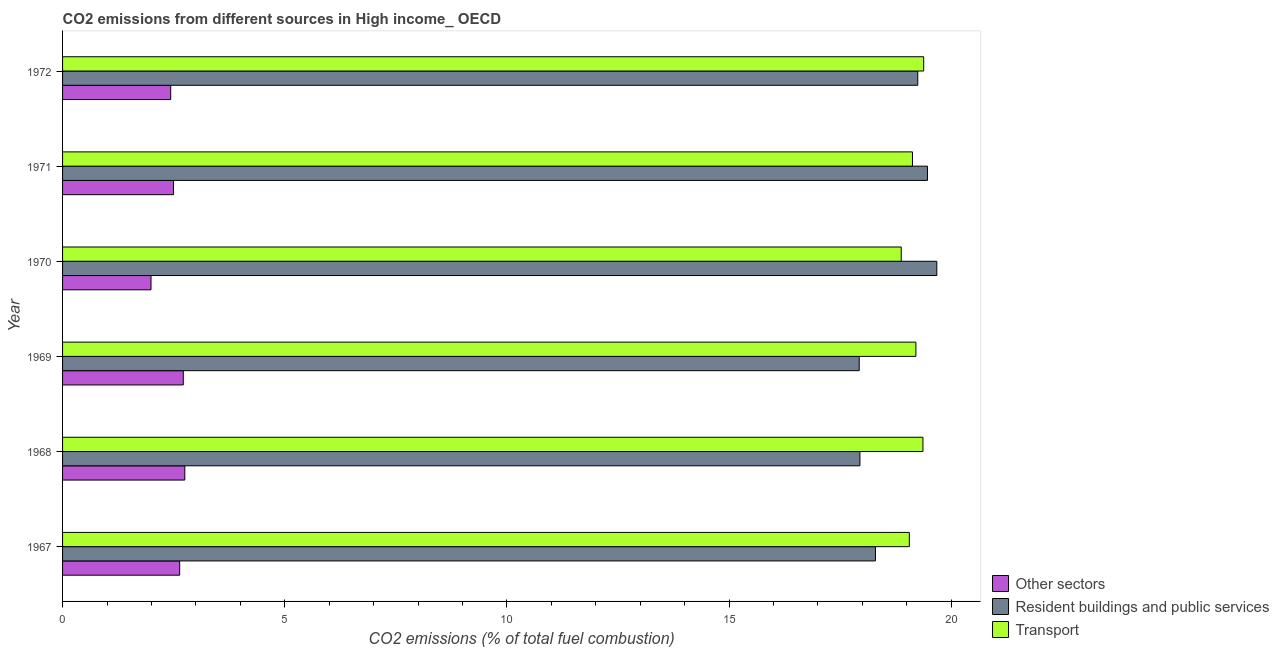How many different coloured bars are there?
Provide a succinct answer. 3. Are the number of bars on each tick of the Y-axis equal?
Keep it short and to the point. Yes. How many bars are there on the 5th tick from the top?
Your answer should be compact. 3. How many bars are there on the 3rd tick from the bottom?
Your answer should be very brief. 3. What is the label of the 5th group of bars from the top?
Keep it short and to the point. 1968. What is the percentage of co2 emissions from other sectors in 1972?
Provide a short and direct response. 2.43. Across all years, what is the maximum percentage of co2 emissions from other sectors?
Your answer should be compact. 2.75. Across all years, what is the minimum percentage of co2 emissions from resident buildings and public services?
Your answer should be compact. 17.93. In which year was the percentage of co2 emissions from other sectors maximum?
Your answer should be compact. 1968. In which year was the percentage of co2 emissions from transport minimum?
Your answer should be compact. 1970. What is the total percentage of co2 emissions from resident buildings and public services in the graph?
Your answer should be very brief. 112.57. What is the difference between the percentage of co2 emissions from resident buildings and public services in 1967 and that in 1969?
Offer a very short reply. 0.36. What is the difference between the percentage of co2 emissions from transport in 1968 and the percentage of co2 emissions from resident buildings and public services in 1969?
Offer a terse response. 1.43. What is the average percentage of co2 emissions from transport per year?
Your answer should be very brief. 19.17. In the year 1972, what is the difference between the percentage of co2 emissions from transport and percentage of co2 emissions from other sectors?
Make the answer very short. 16.95. Is the percentage of co2 emissions from other sectors in 1968 less than that in 1970?
Give a very brief answer. No. What is the difference between the highest and the second highest percentage of co2 emissions from transport?
Ensure brevity in your answer.  0.02. What is the difference between the highest and the lowest percentage of co2 emissions from other sectors?
Offer a terse response. 0.76. In how many years, is the percentage of co2 emissions from other sectors greater than the average percentage of co2 emissions from other sectors taken over all years?
Provide a succinct answer. 3. What does the 2nd bar from the top in 1972 represents?
Keep it short and to the point. Resident buildings and public services. What does the 1st bar from the bottom in 1970 represents?
Offer a very short reply. Other sectors. Is it the case that in every year, the sum of the percentage of co2 emissions from other sectors and percentage of co2 emissions from resident buildings and public services is greater than the percentage of co2 emissions from transport?
Provide a succinct answer. Yes. How many bars are there?
Offer a terse response. 18. Are all the bars in the graph horizontal?
Your answer should be very brief. Yes. What is the difference between two consecutive major ticks on the X-axis?
Your answer should be compact. 5. Does the graph contain any zero values?
Keep it short and to the point. No. Does the graph contain grids?
Your answer should be compact. No. How are the legend labels stacked?
Provide a short and direct response. Vertical. What is the title of the graph?
Make the answer very short. CO2 emissions from different sources in High income_ OECD. Does "Total employers" appear as one of the legend labels in the graph?
Provide a succinct answer. No. What is the label or title of the X-axis?
Keep it short and to the point. CO2 emissions (% of total fuel combustion). What is the CO2 emissions (% of total fuel combustion) in Other sectors in 1967?
Your answer should be compact. 2.64. What is the CO2 emissions (% of total fuel combustion) of Resident buildings and public services in 1967?
Provide a short and direct response. 18.3. What is the CO2 emissions (% of total fuel combustion) of Transport in 1967?
Provide a short and direct response. 19.06. What is the CO2 emissions (% of total fuel combustion) in Other sectors in 1968?
Provide a short and direct response. 2.75. What is the CO2 emissions (% of total fuel combustion) of Resident buildings and public services in 1968?
Ensure brevity in your answer.  17.95. What is the CO2 emissions (% of total fuel combustion) of Transport in 1968?
Provide a short and direct response. 19.37. What is the CO2 emissions (% of total fuel combustion) of Other sectors in 1969?
Your answer should be very brief. 2.72. What is the CO2 emissions (% of total fuel combustion) of Resident buildings and public services in 1969?
Ensure brevity in your answer.  17.93. What is the CO2 emissions (% of total fuel combustion) of Transport in 1969?
Keep it short and to the point. 19.21. What is the CO2 emissions (% of total fuel combustion) of Other sectors in 1970?
Provide a succinct answer. 1.99. What is the CO2 emissions (% of total fuel combustion) of Resident buildings and public services in 1970?
Your response must be concise. 19.68. What is the CO2 emissions (% of total fuel combustion) of Transport in 1970?
Your response must be concise. 18.88. What is the CO2 emissions (% of total fuel combustion) of Other sectors in 1971?
Provide a short and direct response. 2.5. What is the CO2 emissions (% of total fuel combustion) of Resident buildings and public services in 1971?
Your response must be concise. 19.47. What is the CO2 emissions (% of total fuel combustion) in Transport in 1971?
Provide a short and direct response. 19.13. What is the CO2 emissions (% of total fuel combustion) of Other sectors in 1972?
Keep it short and to the point. 2.43. What is the CO2 emissions (% of total fuel combustion) of Resident buildings and public services in 1972?
Your response must be concise. 19.25. What is the CO2 emissions (% of total fuel combustion) in Transport in 1972?
Offer a terse response. 19.38. Across all years, what is the maximum CO2 emissions (% of total fuel combustion) in Other sectors?
Provide a short and direct response. 2.75. Across all years, what is the maximum CO2 emissions (% of total fuel combustion) in Resident buildings and public services?
Make the answer very short. 19.68. Across all years, what is the maximum CO2 emissions (% of total fuel combustion) in Transport?
Give a very brief answer. 19.38. Across all years, what is the minimum CO2 emissions (% of total fuel combustion) of Other sectors?
Offer a very short reply. 1.99. Across all years, what is the minimum CO2 emissions (% of total fuel combustion) in Resident buildings and public services?
Your response must be concise. 17.93. Across all years, what is the minimum CO2 emissions (% of total fuel combustion) of Transport?
Provide a succinct answer. 18.88. What is the total CO2 emissions (% of total fuel combustion) of Other sectors in the graph?
Give a very brief answer. 15.02. What is the total CO2 emissions (% of total fuel combustion) in Resident buildings and public services in the graph?
Offer a very short reply. 112.57. What is the total CO2 emissions (% of total fuel combustion) in Transport in the graph?
Provide a succinct answer. 115.02. What is the difference between the CO2 emissions (% of total fuel combustion) in Other sectors in 1967 and that in 1968?
Your response must be concise. -0.12. What is the difference between the CO2 emissions (% of total fuel combustion) of Resident buildings and public services in 1967 and that in 1968?
Offer a terse response. 0.35. What is the difference between the CO2 emissions (% of total fuel combustion) in Transport in 1967 and that in 1968?
Ensure brevity in your answer.  -0.31. What is the difference between the CO2 emissions (% of total fuel combustion) in Other sectors in 1967 and that in 1969?
Offer a terse response. -0.08. What is the difference between the CO2 emissions (% of total fuel combustion) of Resident buildings and public services in 1967 and that in 1969?
Make the answer very short. 0.37. What is the difference between the CO2 emissions (% of total fuel combustion) of Transport in 1967 and that in 1969?
Give a very brief answer. -0.15. What is the difference between the CO2 emissions (% of total fuel combustion) in Other sectors in 1967 and that in 1970?
Give a very brief answer. 0.65. What is the difference between the CO2 emissions (% of total fuel combustion) in Resident buildings and public services in 1967 and that in 1970?
Your response must be concise. -1.38. What is the difference between the CO2 emissions (% of total fuel combustion) in Transport in 1967 and that in 1970?
Your response must be concise. 0.18. What is the difference between the CO2 emissions (% of total fuel combustion) of Other sectors in 1967 and that in 1971?
Offer a terse response. 0.14. What is the difference between the CO2 emissions (% of total fuel combustion) in Resident buildings and public services in 1967 and that in 1971?
Give a very brief answer. -1.17. What is the difference between the CO2 emissions (% of total fuel combustion) of Transport in 1967 and that in 1971?
Ensure brevity in your answer.  -0.07. What is the difference between the CO2 emissions (% of total fuel combustion) of Other sectors in 1967 and that in 1972?
Make the answer very short. 0.2. What is the difference between the CO2 emissions (% of total fuel combustion) of Resident buildings and public services in 1967 and that in 1972?
Your answer should be compact. -0.95. What is the difference between the CO2 emissions (% of total fuel combustion) of Transport in 1967 and that in 1972?
Offer a very short reply. -0.32. What is the difference between the CO2 emissions (% of total fuel combustion) in Other sectors in 1968 and that in 1969?
Ensure brevity in your answer.  0.03. What is the difference between the CO2 emissions (% of total fuel combustion) in Resident buildings and public services in 1968 and that in 1969?
Give a very brief answer. 0.02. What is the difference between the CO2 emissions (% of total fuel combustion) in Transport in 1968 and that in 1969?
Offer a very short reply. 0.16. What is the difference between the CO2 emissions (% of total fuel combustion) of Other sectors in 1968 and that in 1970?
Offer a terse response. 0.76. What is the difference between the CO2 emissions (% of total fuel combustion) in Resident buildings and public services in 1968 and that in 1970?
Keep it short and to the point. -1.73. What is the difference between the CO2 emissions (% of total fuel combustion) in Transport in 1968 and that in 1970?
Your answer should be very brief. 0.49. What is the difference between the CO2 emissions (% of total fuel combustion) in Other sectors in 1968 and that in 1971?
Keep it short and to the point. 0.26. What is the difference between the CO2 emissions (% of total fuel combustion) of Resident buildings and public services in 1968 and that in 1971?
Provide a short and direct response. -1.52. What is the difference between the CO2 emissions (% of total fuel combustion) of Transport in 1968 and that in 1971?
Make the answer very short. 0.24. What is the difference between the CO2 emissions (% of total fuel combustion) of Other sectors in 1968 and that in 1972?
Keep it short and to the point. 0.32. What is the difference between the CO2 emissions (% of total fuel combustion) in Resident buildings and public services in 1968 and that in 1972?
Ensure brevity in your answer.  -1.3. What is the difference between the CO2 emissions (% of total fuel combustion) of Transport in 1968 and that in 1972?
Offer a terse response. -0.02. What is the difference between the CO2 emissions (% of total fuel combustion) in Other sectors in 1969 and that in 1970?
Offer a terse response. 0.73. What is the difference between the CO2 emissions (% of total fuel combustion) of Resident buildings and public services in 1969 and that in 1970?
Offer a terse response. -1.75. What is the difference between the CO2 emissions (% of total fuel combustion) of Transport in 1969 and that in 1970?
Give a very brief answer. 0.33. What is the difference between the CO2 emissions (% of total fuel combustion) of Other sectors in 1969 and that in 1971?
Ensure brevity in your answer.  0.22. What is the difference between the CO2 emissions (% of total fuel combustion) in Resident buildings and public services in 1969 and that in 1971?
Your response must be concise. -1.54. What is the difference between the CO2 emissions (% of total fuel combustion) of Transport in 1969 and that in 1971?
Your answer should be compact. 0.08. What is the difference between the CO2 emissions (% of total fuel combustion) in Other sectors in 1969 and that in 1972?
Offer a very short reply. 0.28. What is the difference between the CO2 emissions (% of total fuel combustion) of Resident buildings and public services in 1969 and that in 1972?
Provide a succinct answer. -1.32. What is the difference between the CO2 emissions (% of total fuel combustion) of Transport in 1969 and that in 1972?
Provide a succinct answer. -0.18. What is the difference between the CO2 emissions (% of total fuel combustion) in Other sectors in 1970 and that in 1971?
Provide a short and direct response. -0.51. What is the difference between the CO2 emissions (% of total fuel combustion) in Resident buildings and public services in 1970 and that in 1971?
Give a very brief answer. 0.21. What is the difference between the CO2 emissions (% of total fuel combustion) in Transport in 1970 and that in 1971?
Your answer should be very brief. -0.25. What is the difference between the CO2 emissions (% of total fuel combustion) of Other sectors in 1970 and that in 1972?
Your answer should be very brief. -0.44. What is the difference between the CO2 emissions (% of total fuel combustion) in Resident buildings and public services in 1970 and that in 1972?
Your answer should be very brief. 0.43. What is the difference between the CO2 emissions (% of total fuel combustion) in Transport in 1970 and that in 1972?
Keep it short and to the point. -0.51. What is the difference between the CO2 emissions (% of total fuel combustion) of Other sectors in 1971 and that in 1972?
Offer a very short reply. 0.06. What is the difference between the CO2 emissions (% of total fuel combustion) in Resident buildings and public services in 1971 and that in 1972?
Your answer should be compact. 0.22. What is the difference between the CO2 emissions (% of total fuel combustion) in Transport in 1971 and that in 1972?
Your response must be concise. -0.25. What is the difference between the CO2 emissions (% of total fuel combustion) of Other sectors in 1967 and the CO2 emissions (% of total fuel combustion) of Resident buildings and public services in 1968?
Give a very brief answer. -15.31. What is the difference between the CO2 emissions (% of total fuel combustion) of Other sectors in 1967 and the CO2 emissions (% of total fuel combustion) of Transport in 1968?
Keep it short and to the point. -16.73. What is the difference between the CO2 emissions (% of total fuel combustion) in Resident buildings and public services in 1967 and the CO2 emissions (% of total fuel combustion) in Transport in 1968?
Give a very brief answer. -1.07. What is the difference between the CO2 emissions (% of total fuel combustion) in Other sectors in 1967 and the CO2 emissions (% of total fuel combustion) in Resident buildings and public services in 1969?
Provide a succinct answer. -15.29. What is the difference between the CO2 emissions (% of total fuel combustion) of Other sectors in 1967 and the CO2 emissions (% of total fuel combustion) of Transport in 1969?
Provide a succinct answer. -16.57. What is the difference between the CO2 emissions (% of total fuel combustion) of Resident buildings and public services in 1967 and the CO2 emissions (% of total fuel combustion) of Transport in 1969?
Ensure brevity in your answer.  -0.91. What is the difference between the CO2 emissions (% of total fuel combustion) in Other sectors in 1967 and the CO2 emissions (% of total fuel combustion) in Resident buildings and public services in 1970?
Make the answer very short. -17.04. What is the difference between the CO2 emissions (% of total fuel combustion) in Other sectors in 1967 and the CO2 emissions (% of total fuel combustion) in Transport in 1970?
Make the answer very short. -16.24. What is the difference between the CO2 emissions (% of total fuel combustion) of Resident buildings and public services in 1967 and the CO2 emissions (% of total fuel combustion) of Transport in 1970?
Ensure brevity in your answer.  -0.58. What is the difference between the CO2 emissions (% of total fuel combustion) of Other sectors in 1967 and the CO2 emissions (% of total fuel combustion) of Resident buildings and public services in 1971?
Provide a short and direct response. -16.83. What is the difference between the CO2 emissions (% of total fuel combustion) in Other sectors in 1967 and the CO2 emissions (% of total fuel combustion) in Transport in 1971?
Offer a very short reply. -16.49. What is the difference between the CO2 emissions (% of total fuel combustion) of Resident buildings and public services in 1967 and the CO2 emissions (% of total fuel combustion) of Transport in 1971?
Your response must be concise. -0.83. What is the difference between the CO2 emissions (% of total fuel combustion) of Other sectors in 1967 and the CO2 emissions (% of total fuel combustion) of Resident buildings and public services in 1972?
Keep it short and to the point. -16.61. What is the difference between the CO2 emissions (% of total fuel combustion) in Other sectors in 1967 and the CO2 emissions (% of total fuel combustion) in Transport in 1972?
Ensure brevity in your answer.  -16.75. What is the difference between the CO2 emissions (% of total fuel combustion) of Resident buildings and public services in 1967 and the CO2 emissions (% of total fuel combustion) of Transport in 1972?
Keep it short and to the point. -1.09. What is the difference between the CO2 emissions (% of total fuel combustion) of Other sectors in 1968 and the CO2 emissions (% of total fuel combustion) of Resident buildings and public services in 1969?
Your response must be concise. -15.18. What is the difference between the CO2 emissions (% of total fuel combustion) in Other sectors in 1968 and the CO2 emissions (% of total fuel combustion) in Transport in 1969?
Keep it short and to the point. -16.45. What is the difference between the CO2 emissions (% of total fuel combustion) in Resident buildings and public services in 1968 and the CO2 emissions (% of total fuel combustion) in Transport in 1969?
Give a very brief answer. -1.26. What is the difference between the CO2 emissions (% of total fuel combustion) of Other sectors in 1968 and the CO2 emissions (% of total fuel combustion) of Resident buildings and public services in 1970?
Your answer should be very brief. -16.93. What is the difference between the CO2 emissions (% of total fuel combustion) in Other sectors in 1968 and the CO2 emissions (% of total fuel combustion) in Transport in 1970?
Offer a very short reply. -16.12. What is the difference between the CO2 emissions (% of total fuel combustion) of Resident buildings and public services in 1968 and the CO2 emissions (% of total fuel combustion) of Transport in 1970?
Your answer should be very brief. -0.93. What is the difference between the CO2 emissions (% of total fuel combustion) of Other sectors in 1968 and the CO2 emissions (% of total fuel combustion) of Resident buildings and public services in 1971?
Your response must be concise. -16.72. What is the difference between the CO2 emissions (% of total fuel combustion) of Other sectors in 1968 and the CO2 emissions (% of total fuel combustion) of Transport in 1971?
Provide a succinct answer. -16.38. What is the difference between the CO2 emissions (% of total fuel combustion) in Resident buildings and public services in 1968 and the CO2 emissions (% of total fuel combustion) in Transport in 1971?
Give a very brief answer. -1.18. What is the difference between the CO2 emissions (% of total fuel combustion) of Other sectors in 1968 and the CO2 emissions (% of total fuel combustion) of Resident buildings and public services in 1972?
Your answer should be compact. -16.5. What is the difference between the CO2 emissions (% of total fuel combustion) in Other sectors in 1968 and the CO2 emissions (% of total fuel combustion) in Transport in 1972?
Keep it short and to the point. -16.63. What is the difference between the CO2 emissions (% of total fuel combustion) of Resident buildings and public services in 1968 and the CO2 emissions (% of total fuel combustion) of Transport in 1972?
Your answer should be compact. -1.44. What is the difference between the CO2 emissions (% of total fuel combustion) in Other sectors in 1969 and the CO2 emissions (% of total fuel combustion) in Resident buildings and public services in 1970?
Your answer should be very brief. -16.96. What is the difference between the CO2 emissions (% of total fuel combustion) of Other sectors in 1969 and the CO2 emissions (% of total fuel combustion) of Transport in 1970?
Make the answer very short. -16.16. What is the difference between the CO2 emissions (% of total fuel combustion) of Resident buildings and public services in 1969 and the CO2 emissions (% of total fuel combustion) of Transport in 1970?
Give a very brief answer. -0.95. What is the difference between the CO2 emissions (% of total fuel combustion) of Other sectors in 1969 and the CO2 emissions (% of total fuel combustion) of Resident buildings and public services in 1971?
Offer a very short reply. -16.75. What is the difference between the CO2 emissions (% of total fuel combustion) in Other sectors in 1969 and the CO2 emissions (% of total fuel combustion) in Transport in 1971?
Make the answer very short. -16.41. What is the difference between the CO2 emissions (% of total fuel combustion) in Resident buildings and public services in 1969 and the CO2 emissions (% of total fuel combustion) in Transport in 1971?
Offer a terse response. -1.2. What is the difference between the CO2 emissions (% of total fuel combustion) in Other sectors in 1969 and the CO2 emissions (% of total fuel combustion) in Resident buildings and public services in 1972?
Provide a succinct answer. -16.53. What is the difference between the CO2 emissions (% of total fuel combustion) in Other sectors in 1969 and the CO2 emissions (% of total fuel combustion) in Transport in 1972?
Make the answer very short. -16.66. What is the difference between the CO2 emissions (% of total fuel combustion) of Resident buildings and public services in 1969 and the CO2 emissions (% of total fuel combustion) of Transport in 1972?
Keep it short and to the point. -1.45. What is the difference between the CO2 emissions (% of total fuel combustion) in Other sectors in 1970 and the CO2 emissions (% of total fuel combustion) in Resident buildings and public services in 1971?
Offer a very short reply. -17.48. What is the difference between the CO2 emissions (% of total fuel combustion) of Other sectors in 1970 and the CO2 emissions (% of total fuel combustion) of Transport in 1971?
Provide a short and direct response. -17.14. What is the difference between the CO2 emissions (% of total fuel combustion) in Resident buildings and public services in 1970 and the CO2 emissions (% of total fuel combustion) in Transport in 1971?
Offer a very short reply. 0.55. What is the difference between the CO2 emissions (% of total fuel combustion) of Other sectors in 1970 and the CO2 emissions (% of total fuel combustion) of Resident buildings and public services in 1972?
Your answer should be very brief. -17.26. What is the difference between the CO2 emissions (% of total fuel combustion) in Other sectors in 1970 and the CO2 emissions (% of total fuel combustion) in Transport in 1972?
Make the answer very short. -17.39. What is the difference between the CO2 emissions (% of total fuel combustion) in Resident buildings and public services in 1970 and the CO2 emissions (% of total fuel combustion) in Transport in 1972?
Provide a succinct answer. 0.3. What is the difference between the CO2 emissions (% of total fuel combustion) of Other sectors in 1971 and the CO2 emissions (% of total fuel combustion) of Resident buildings and public services in 1972?
Your answer should be very brief. -16.75. What is the difference between the CO2 emissions (% of total fuel combustion) of Other sectors in 1971 and the CO2 emissions (% of total fuel combustion) of Transport in 1972?
Your answer should be compact. -16.89. What is the difference between the CO2 emissions (% of total fuel combustion) in Resident buildings and public services in 1971 and the CO2 emissions (% of total fuel combustion) in Transport in 1972?
Make the answer very short. 0.09. What is the average CO2 emissions (% of total fuel combustion) in Other sectors per year?
Provide a short and direct response. 2.5. What is the average CO2 emissions (% of total fuel combustion) of Resident buildings and public services per year?
Offer a terse response. 18.76. What is the average CO2 emissions (% of total fuel combustion) of Transport per year?
Give a very brief answer. 19.17. In the year 1967, what is the difference between the CO2 emissions (% of total fuel combustion) of Other sectors and CO2 emissions (% of total fuel combustion) of Resident buildings and public services?
Keep it short and to the point. -15.66. In the year 1967, what is the difference between the CO2 emissions (% of total fuel combustion) in Other sectors and CO2 emissions (% of total fuel combustion) in Transport?
Your response must be concise. -16.42. In the year 1967, what is the difference between the CO2 emissions (% of total fuel combustion) in Resident buildings and public services and CO2 emissions (% of total fuel combustion) in Transport?
Provide a succinct answer. -0.76. In the year 1968, what is the difference between the CO2 emissions (% of total fuel combustion) of Other sectors and CO2 emissions (% of total fuel combustion) of Resident buildings and public services?
Your answer should be compact. -15.2. In the year 1968, what is the difference between the CO2 emissions (% of total fuel combustion) of Other sectors and CO2 emissions (% of total fuel combustion) of Transport?
Offer a terse response. -16.61. In the year 1968, what is the difference between the CO2 emissions (% of total fuel combustion) in Resident buildings and public services and CO2 emissions (% of total fuel combustion) in Transport?
Provide a short and direct response. -1.42. In the year 1969, what is the difference between the CO2 emissions (% of total fuel combustion) in Other sectors and CO2 emissions (% of total fuel combustion) in Resident buildings and public services?
Provide a short and direct response. -15.21. In the year 1969, what is the difference between the CO2 emissions (% of total fuel combustion) in Other sectors and CO2 emissions (% of total fuel combustion) in Transport?
Make the answer very short. -16.49. In the year 1969, what is the difference between the CO2 emissions (% of total fuel combustion) in Resident buildings and public services and CO2 emissions (% of total fuel combustion) in Transport?
Offer a very short reply. -1.28. In the year 1970, what is the difference between the CO2 emissions (% of total fuel combustion) in Other sectors and CO2 emissions (% of total fuel combustion) in Resident buildings and public services?
Provide a short and direct response. -17.69. In the year 1970, what is the difference between the CO2 emissions (% of total fuel combustion) of Other sectors and CO2 emissions (% of total fuel combustion) of Transport?
Offer a very short reply. -16.89. In the year 1970, what is the difference between the CO2 emissions (% of total fuel combustion) of Resident buildings and public services and CO2 emissions (% of total fuel combustion) of Transport?
Provide a short and direct response. 0.8. In the year 1971, what is the difference between the CO2 emissions (% of total fuel combustion) in Other sectors and CO2 emissions (% of total fuel combustion) in Resident buildings and public services?
Provide a short and direct response. -16.97. In the year 1971, what is the difference between the CO2 emissions (% of total fuel combustion) of Other sectors and CO2 emissions (% of total fuel combustion) of Transport?
Give a very brief answer. -16.63. In the year 1971, what is the difference between the CO2 emissions (% of total fuel combustion) of Resident buildings and public services and CO2 emissions (% of total fuel combustion) of Transport?
Offer a terse response. 0.34. In the year 1972, what is the difference between the CO2 emissions (% of total fuel combustion) in Other sectors and CO2 emissions (% of total fuel combustion) in Resident buildings and public services?
Offer a very short reply. -16.81. In the year 1972, what is the difference between the CO2 emissions (% of total fuel combustion) of Other sectors and CO2 emissions (% of total fuel combustion) of Transport?
Provide a short and direct response. -16.95. In the year 1972, what is the difference between the CO2 emissions (% of total fuel combustion) in Resident buildings and public services and CO2 emissions (% of total fuel combustion) in Transport?
Your response must be concise. -0.13. What is the ratio of the CO2 emissions (% of total fuel combustion) in Other sectors in 1967 to that in 1968?
Give a very brief answer. 0.96. What is the ratio of the CO2 emissions (% of total fuel combustion) of Resident buildings and public services in 1967 to that in 1968?
Your answer should be compact. 1.02. What is the ratio of the CO2 emissions (% of total fuel combustion) of Transport in 1967 to that in 1968?
Offer a very short reply. 0.98. What is the ratio of the CO2 emissions (% of total fuel combustion) of Other sectors in 1967 to that in 1969?
Your response must be concise. 0.97. What is the ratio of the CO2 emissions (% of total fuel combustion) in Resident buildings and public services in 1967 to that in 1969?
Offer a terse response. 1.02. What is the ratio of the CO2 emissions (% of total fuel combustion) in Transport in 1967 to that in 1969?
Give a very brief answer. 0.99. What is the ratio of the CO2 emissions (% of total fuel combustion) in Other sectors in 1967 to that in 1970?
Offer a very short reply. 1.32. What is the ratio of the CO2 emissions (% of total fuel combustion) in Resident buildings and public services in 1967 to that in 1970?
Keep it short and to the point. 0.93. What is the ratio of the CO2 emissions (% of total fuel combustion) of Transport in 1967 to that in 1970?
Your response must be concise. 1.01. What is the ratio of the CO2 emissions (% of total fuel combustion) of Other sectors in 1967 to that in 1971?
Offer a very short reply. 1.06. What is the ratio of the CO2 emissions (% of total fuel combustion) in Resident buildings and public services in 1967 to that in 1971?
Offer a terse response. 0.94. What is the ratio of the CO2 emissions (% of total fuel combustion) of Other sectors in 1967 to that in 1972?
Make the answer very short. 1.08. What is the ratio of the CO2 emissions (% of total fuel combustion) in Resident buildings and public services in 1967 to that in 1972?
Offer a very short reply. 0.95. What is the ratio of the CO2 emissions (% of total fuel combustion) of Transport in 1967 to that in 1972?
Your answer should be compact. 0.98. What is the ratio of the CO2 emissions (% of total fuel combustion) in Other sectors in 1968 to that in 1969?
Give a very brief answer. 1.01. What is the ratio of the CO2 emissions (% of total fuel combustion) in Resident buildings and public services in 1968 to that in 1969?
Your answer should be compact. 1. What is the ratio of the CO2 emissions (% of total fuel combustion) in Transport in 1968 to that in 1969?
Make the answer very short. 1.01. What is the ratio of the CO2 emissions (% of total fuel combustion) of Other sectors in 1968 to that in 1970?
Offer a very short reply. 1.38. What is the ratio of the CO2 emissions (% of total fuel combustion) in Resident buildings and public services in 1968 to that in 1970?
Your answer should be compact. 0.91. What is the ratio of the CO2 emissions (% of total fuel combustion) of Transport in 1968 to that in 1970?
Ensure brevity in your answer.  1.03. What is the ratio of the CO2 emissions (% of total fuel combustion) of Other sectors in 1968 to that in 1971?
Ensure brevity in your answer.  1.1. What is the ratio of the CO2 emissions (% of total fuel combustion) in Resident buildings and public services in 1968 to that in 1971?
Provide a succinct answer. 0.92. What is the ratio of the CO2 emissions (% of total fuel combustion) of Transport in 1968 to that in 1971?
Give a very brief answer. 1.01. What is the ratio of the CO2 emissions (% of total fuel combustion) in Other sectors in 1968 to that in 1972?
Your answer should be very brief. 1.13. What is the ratio of the CO2 emissions (% of total fuel combustion) of Resident buildings and public services in 1968 to that in 1972?
Make the answer very short. 0.93. What is the ratio of the CO2 emissions (% of total fuel combustion) in Transport in 1968 to that in 1972?
Keep it short and to the point. 1. What is the ratio of the CO2 emissions (% of total fuel combustion) of Other sectors in 1969 to that in 1970?
Make the answer very short. 1.36. What is the ratio of the CO2 emissions (% of total fuel combustion) of Resident buildings and public services in 1969 to that in 1970?
Your answer should be compact. 0.91. What is the ratio of the CO2 emissions (% of total fuel combustion) in Transport in 1969 to that in 1970?
Provide a succinct answer. 1.02. What is the ratio of the CO2 emissions (% of total fuel combustion) of Other sectors in 1969 to that in 1971?
Offer a very short reply. 1.09. What is the ratio of the CO2 emissions (% of total fuel combustion) of Resident buildings and public services in 1969 to that in 1971?
Offer a terse response. 0.92. What is the ratio of the CO2 emissions (% of total fuel combustion) of Transport in 1969 to that in 1971?
Make the answer very short. 1. What is the ratio of the CO2 emissions (% of total fuel combustion) of Other sectors in 1969 to that in 1972?
Offer a terse response. 1.12. What is the ratio of the CO2 emissions (% of total fuel combustion) of Resident buildings and public services in 1969 to that in 1972?
Your response must be concise. 0.93. What is the ratio of the CO2 emissions (% of total fuel combustion) of Other sectors in 1970 to that in 1971?
Your answer should be compact. 0.8. What is the ratio of the CO2 emissions (% of total fuel combustion) in Resident buildings and public services in 1970 to that in 1971?
Offer a very short reply. 1.01. What is the ratio of the CO2 emissions (% of total fuel combustion) of Other sectors in 1970 to that in 1972?
Make the answer very short. 0.82. What is the ratio of the CO2 emissions (% of total fuel combustion) of Resident buildings and public services in 1970 to that in 1972?
Offer a terse response. 1.02. What is the ratio of the CO2 emissions (% of total fuel combustion) in Transport in 1970 to that in 1972?
Offer a terse response. 0.97. What is the ratio of the CO2 emissions (% of total fuel combustion) in Other sectors in 1971 to that in 1972?
Your response must be concise. 1.03. What is the ratio of the CO2 emissions (% of total fuel combustion) in Resident buildings and public services in 1971 to that in 1972?
Ensure brevity in your answer.  1.01. What is the ratio of the CO2 emissions (% of total fuel combustion) in Transport in 1971 to that in 1972?
Your response must be concise. 0.99. What is the difference between the highest and the second highest CO2 emissions (% of total fuel combustion) in Other sectors?
Offer a very short reply. 0.03. What is the difference between the highest and the second highest CO2 emissions (% of total fuel combustion) of Resident buildings and public services?
Keep it short and to the point. 0.21. What is the difference between the highest and the second highest CO2 emissions (% of total fuel combustion) in Transport?
Offer a terse response. 0.02. What is the difference between the highest and the lowest CO2 emissions (% of total fuel combustion) of Other sectors?
Offer a very short reply. 0.76. What is the difference between the highest and the lowest CO2 emissions (% of total fuel combustion) of Resident buildings and public services?
Your answer should be very brief. 1.75. What is the difference between the highest and the lowest CO2 emissions (% of total fuel combustion) in Transport?
Make the answer very short. 0.51. 